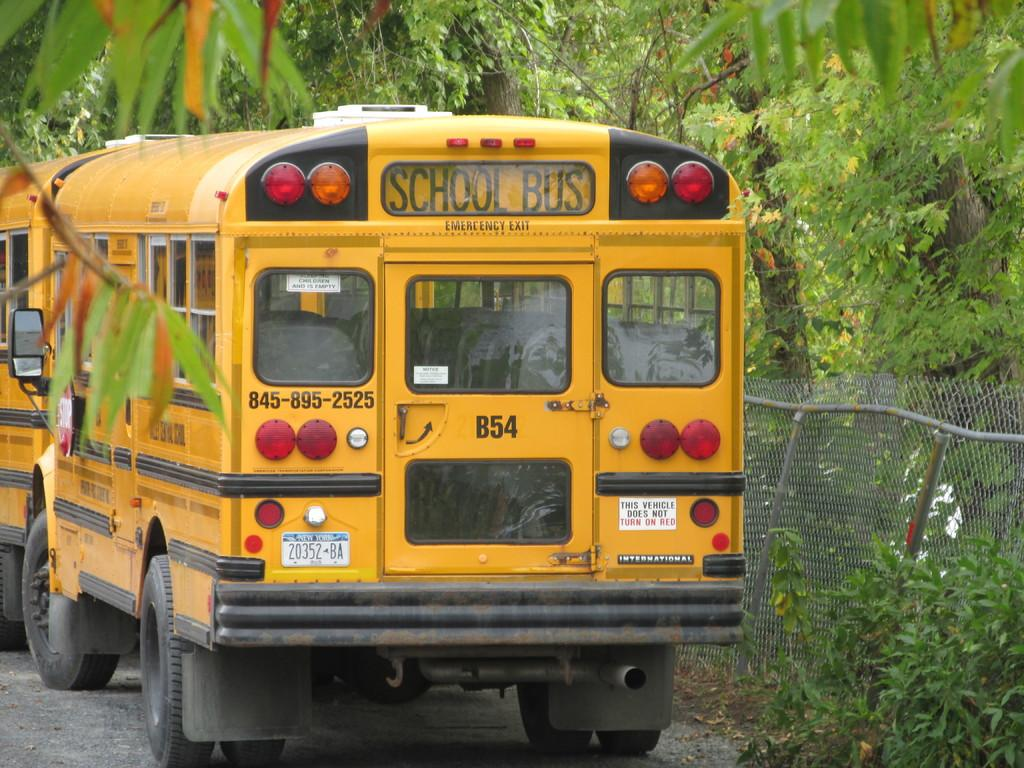What type of vehicles are present in the image? There are yellow color buses in the image. What features do the buses have? The buses have lights and windows. Is there any text visible on the buses? Yes, there is text written on the buses. What can be seen on the right side of the image? There is fencing on the right side of the image. What type of vegetation is present in the image? There are trees in the image. What type of linen is being used to cover the camp in the image? There is no camp or linen present in the image; it features yellow color buses, fencing, and trees. 